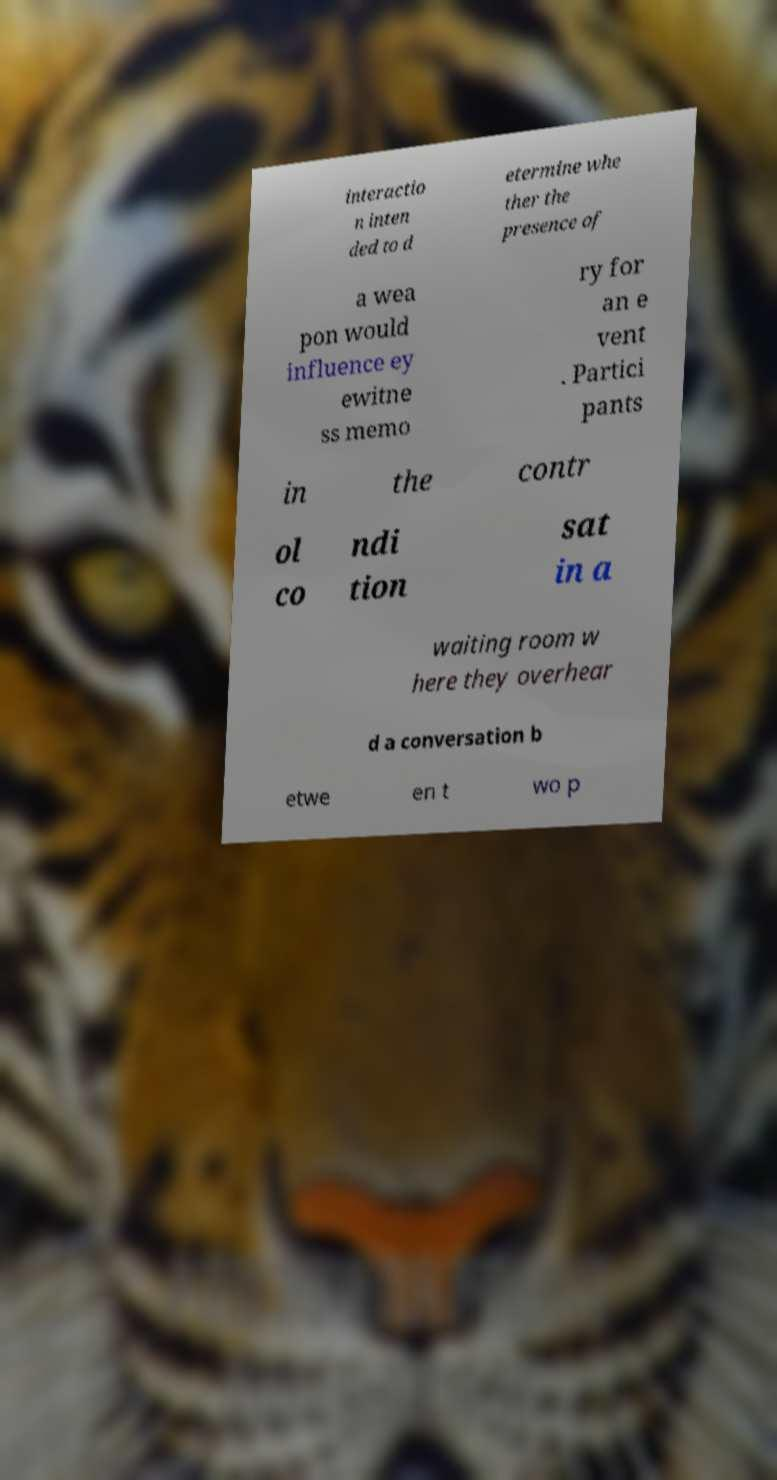Please read and relay the text visible in this image. What does it say? interactio n inten ded to d etermine whe ther the presence of a wea pon would influence ey ewitne ss memo ry for an e vent . Partici pants in the contr ol co ndi tion sat in a waiting room w here they overhear d a conversation b etwe en t wo p 